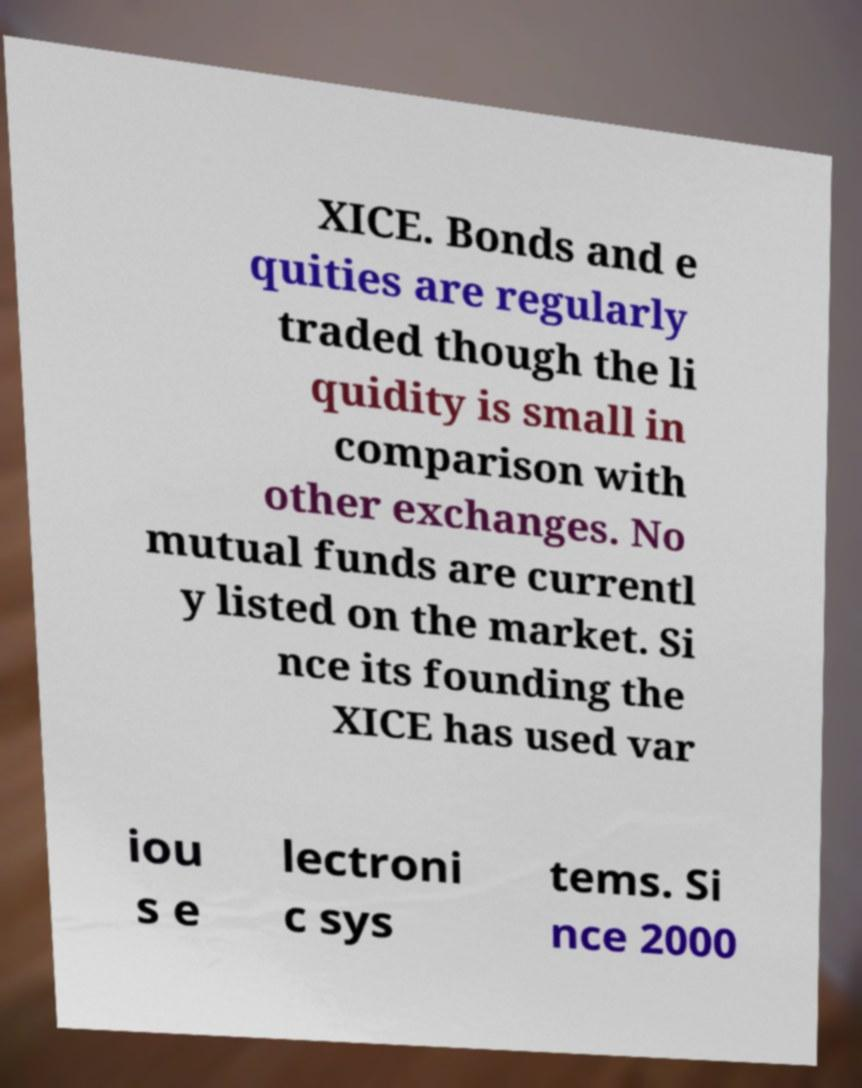Please read and relay the text visible in this image. What does it say? XICE. Bonds and e quities are regularly traded though the li quidity is small in comparison with other exchanges. No mutual funds are currentl y listed on the market. Si nce its founding the XICE has used var iou s e lectroni c sys tems. Si nce 2000 